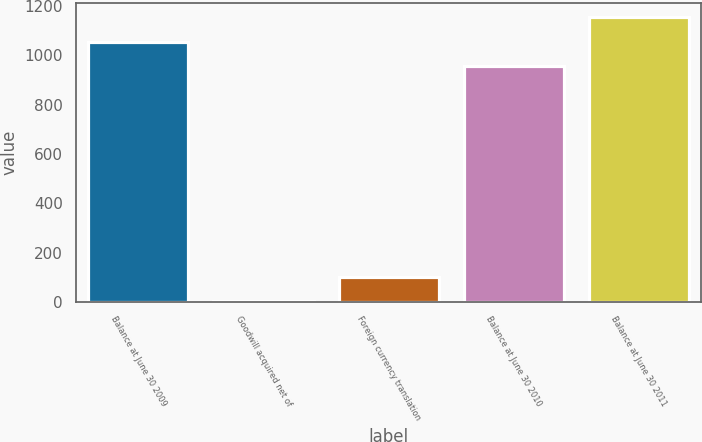<chart> <loc_0><loc_0><loc_500><loc_500><bar_chart><fcel>Balance at June 30 2009<fcel>Goodwill acquired net of<fcel>Foreign currency translation<fcel>Balance at June 30 2010<fcel>Balance at June 30 2011<nl><fcel>1056.18<fcel>1.13<fcel>100.31<fcel>957<fcel>1155.36<nl></chart> 